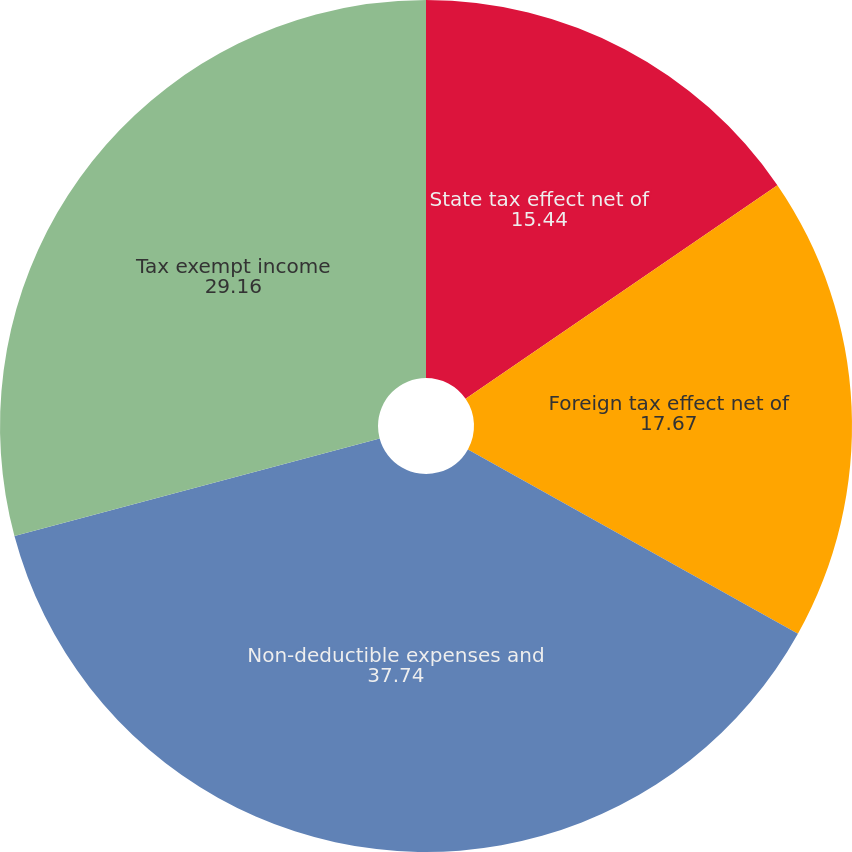<chart> <loc_0><loc_0><loc_500><loc_500><pie_chart><fcel>State tax effect net of<fcel>Foreign tax effect net of<fcel>Non-deductible expenses and<fcel>Tax exempt income<nl><fcel>15.44%<fcel>17.67%<fcel>37.74%<fcel>29.16%<nl></chart> 